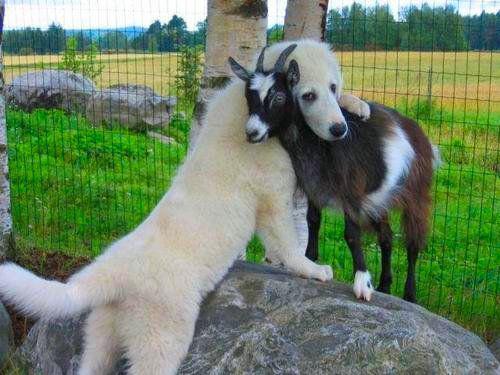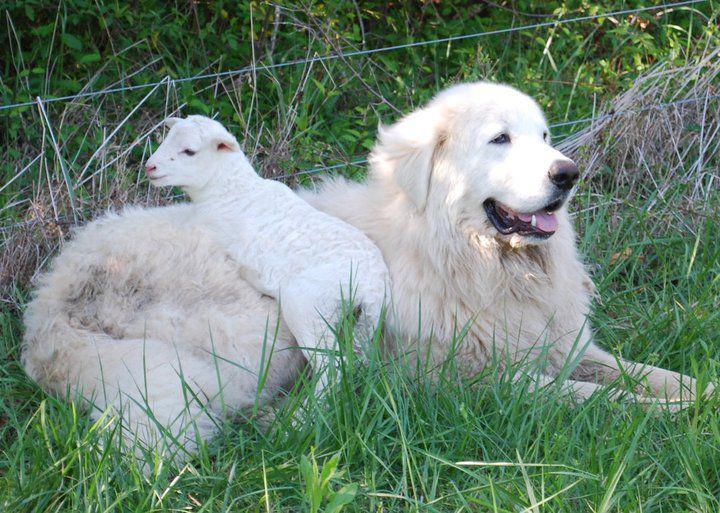The first image is the image on the left, the second image is the image on the right. Given the left and right images, does the statement "There is a baby goat on a dog in one of the images." hold true? Answer yes or no. Yes. The first image is the image on the left, the second image is the image on the right. For the images displayed, is the sentence "An image shows a white dog behind a wire fence with a herd of livestock." factually correct? Answer yes or no. No. 